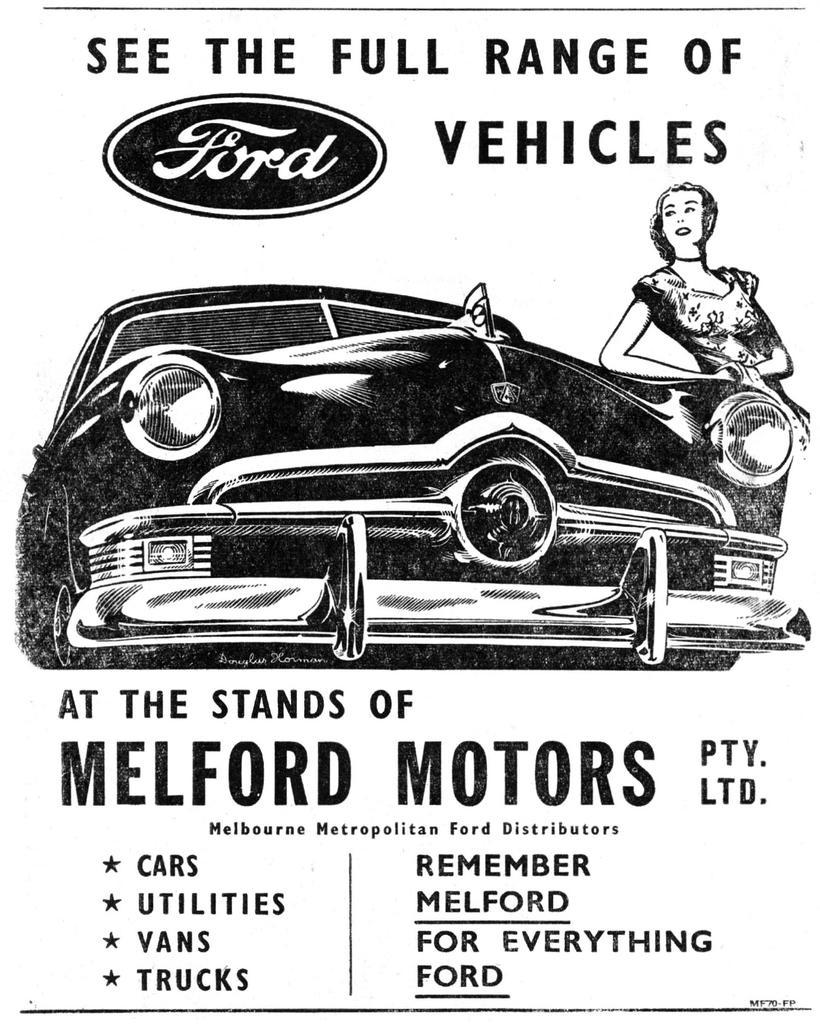Could you give a brief overview of what you see in this image? In this image there is a black and white poster , in that poster there is a car, beside the car there is a lady and o above the car and below the car there is some text written. 